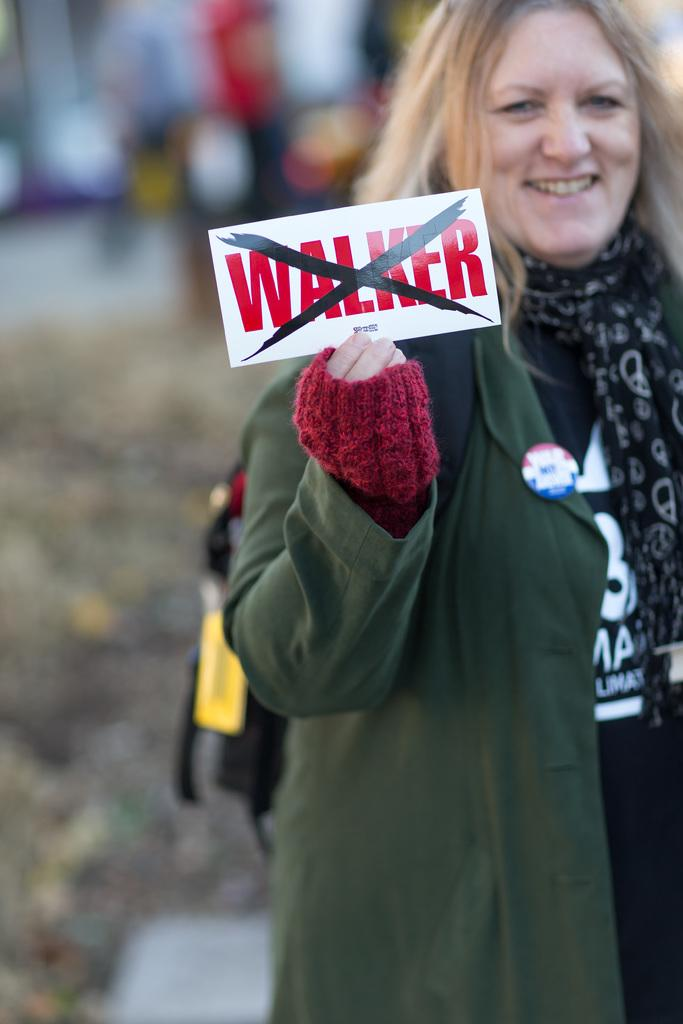Who is present in the image? There is a woman in the image. What is the woman holding in the image? The woman is holding a card. What is the woman's facial expression in the image? The woman is smiling. How is the background of the woman depicted in the image? The background of the woman is blurred. What is the woman's favorite hobby in the image? There is no information about the woman's hobbies in the image. What type of office is visible in the background of the image? There is no office present in the image; the background is blurred. 